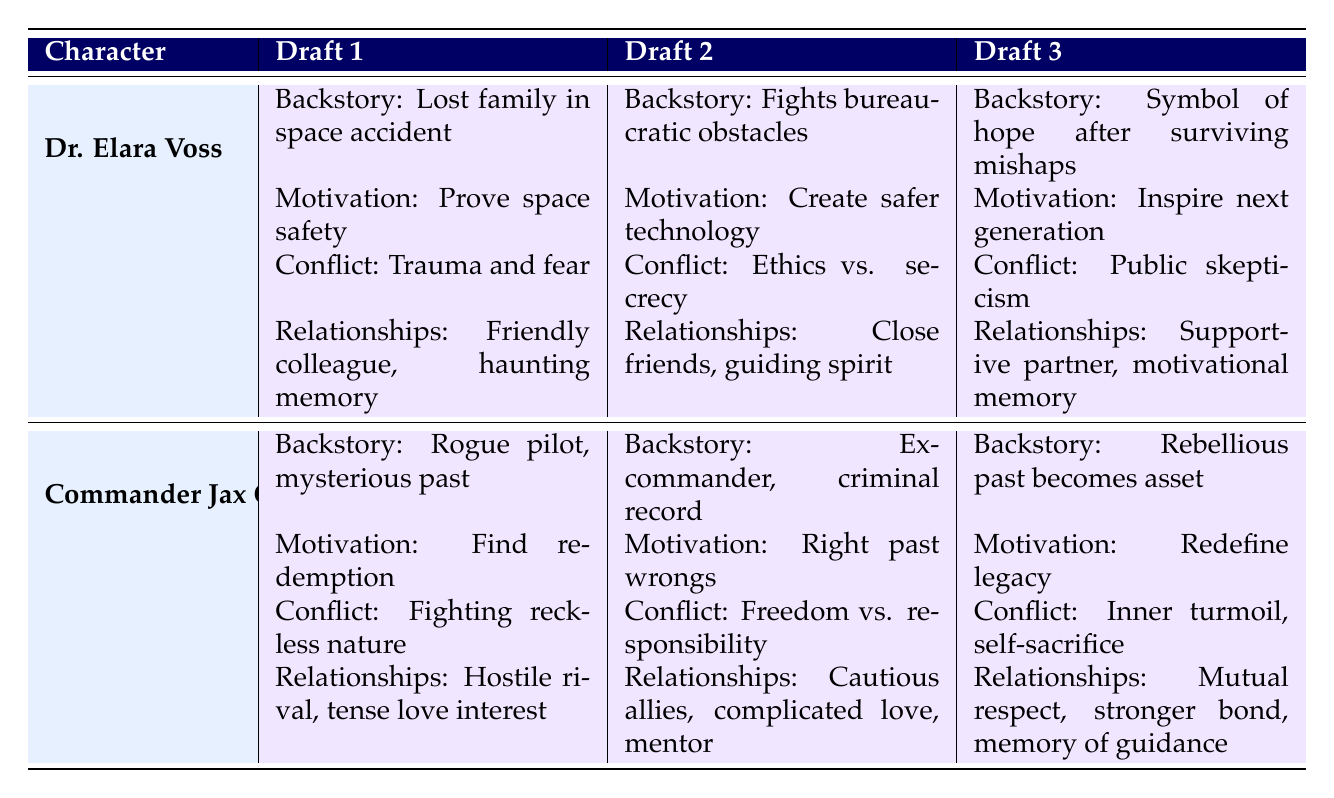What is the backstory of Dr. Elara Voss in Draft 2? According to the table, the backstory for Dr. Elara Voss in Draft 2 is described as "A brilliant scientist with a tragic past details her fight against bureaucratic obstacles."
Answer: A brilliant scientist with a tragic past details her fight against bureaucratic obstacles What relationships does Commander Jax Orion have in Draft 3? In Draft 3, Commander Jax Orion has three relationships: with Lyra Zane (Rival, Status: Mutual Respect), Dr. Elara Voss (Love Interest, Status: Stronger Bond), and Old Mentor (Mentor, Status: Memory of Guidance).
Answer: Lyra Zane (Mutual Respect), Dr. Elara Voss (Stronger Bond), Old Mentor (Memory of Guidance) True or False: Dr. Elara Voss's motivation in Draft 1 is to inspire the next generation of explorers. According to the table, Dr. Elara Voss's motivation in Draft 1 is "To prove that space can be safe for everyone," which is different from inspiring explorers. Therefore, it is False.
Answer: False What is the change in conflict for Commander Jax Orion from Draft 1 to Draft 3? In Draft 1, Jax's conflict is "Fighting against his own reckless nature." By Draft 2, it evolves to "Battles between his desire for freedom and responsibility," and in Draft 3, it becomes "Inner turmoil as he sacrifices for others." This shows a progression from personal recklessness to greater selflessness and responsibility.
Answer: From personal recklessness to self-sacrifice Which character's relationships develop from "Friendly" to "Supportive Partner"? Dr. Elara Voss's relationship with Sam Kellan develops from "Friendly" in Draft 1 to "Supportive Partner" in Draft 3 according to the table.
Answer: Dr. Elara Voss's relationships 